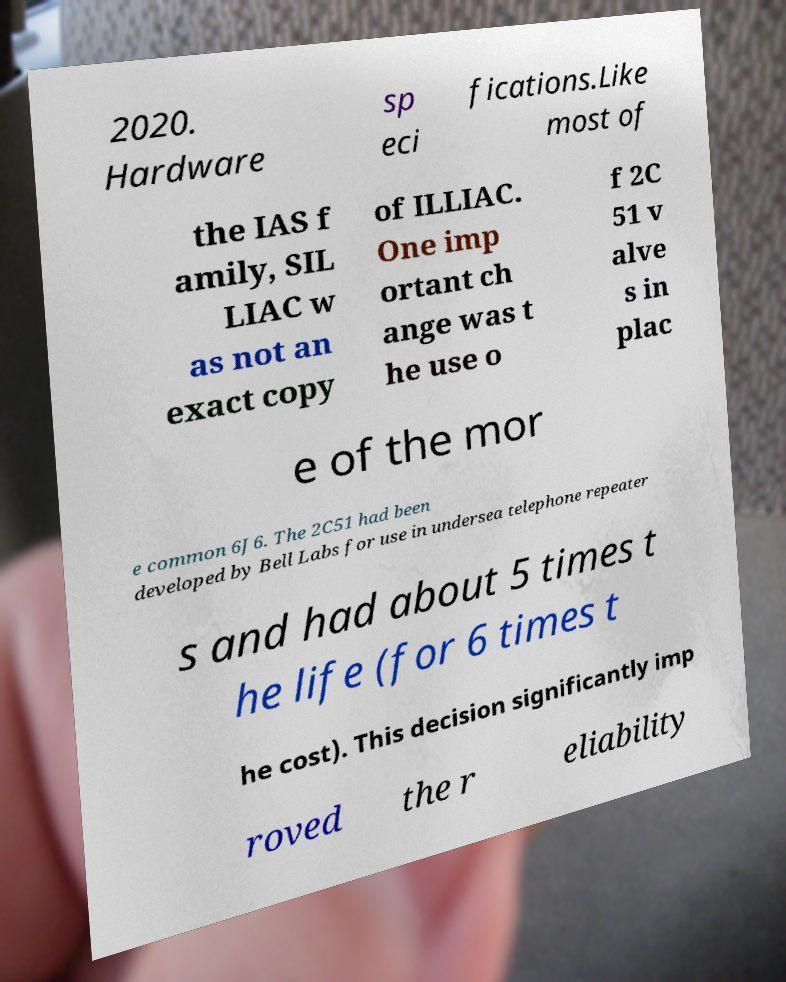Could you extract and type out the text from this image? 2020. Hardware sp eci fications.Like most of the IAS f amily, SIL LIAC w as not an exact copy of ILLIAC. One imp ortant ch ange was t he use o f 2C 51 v alve s in plac e of the mor e common 6J6. The 2C51 had been developed by Bell Labs for use in undersea telephone repeater s and had about 5 times t he life (for 6 times t he cost). This decision significantly imp roved the r eliability 